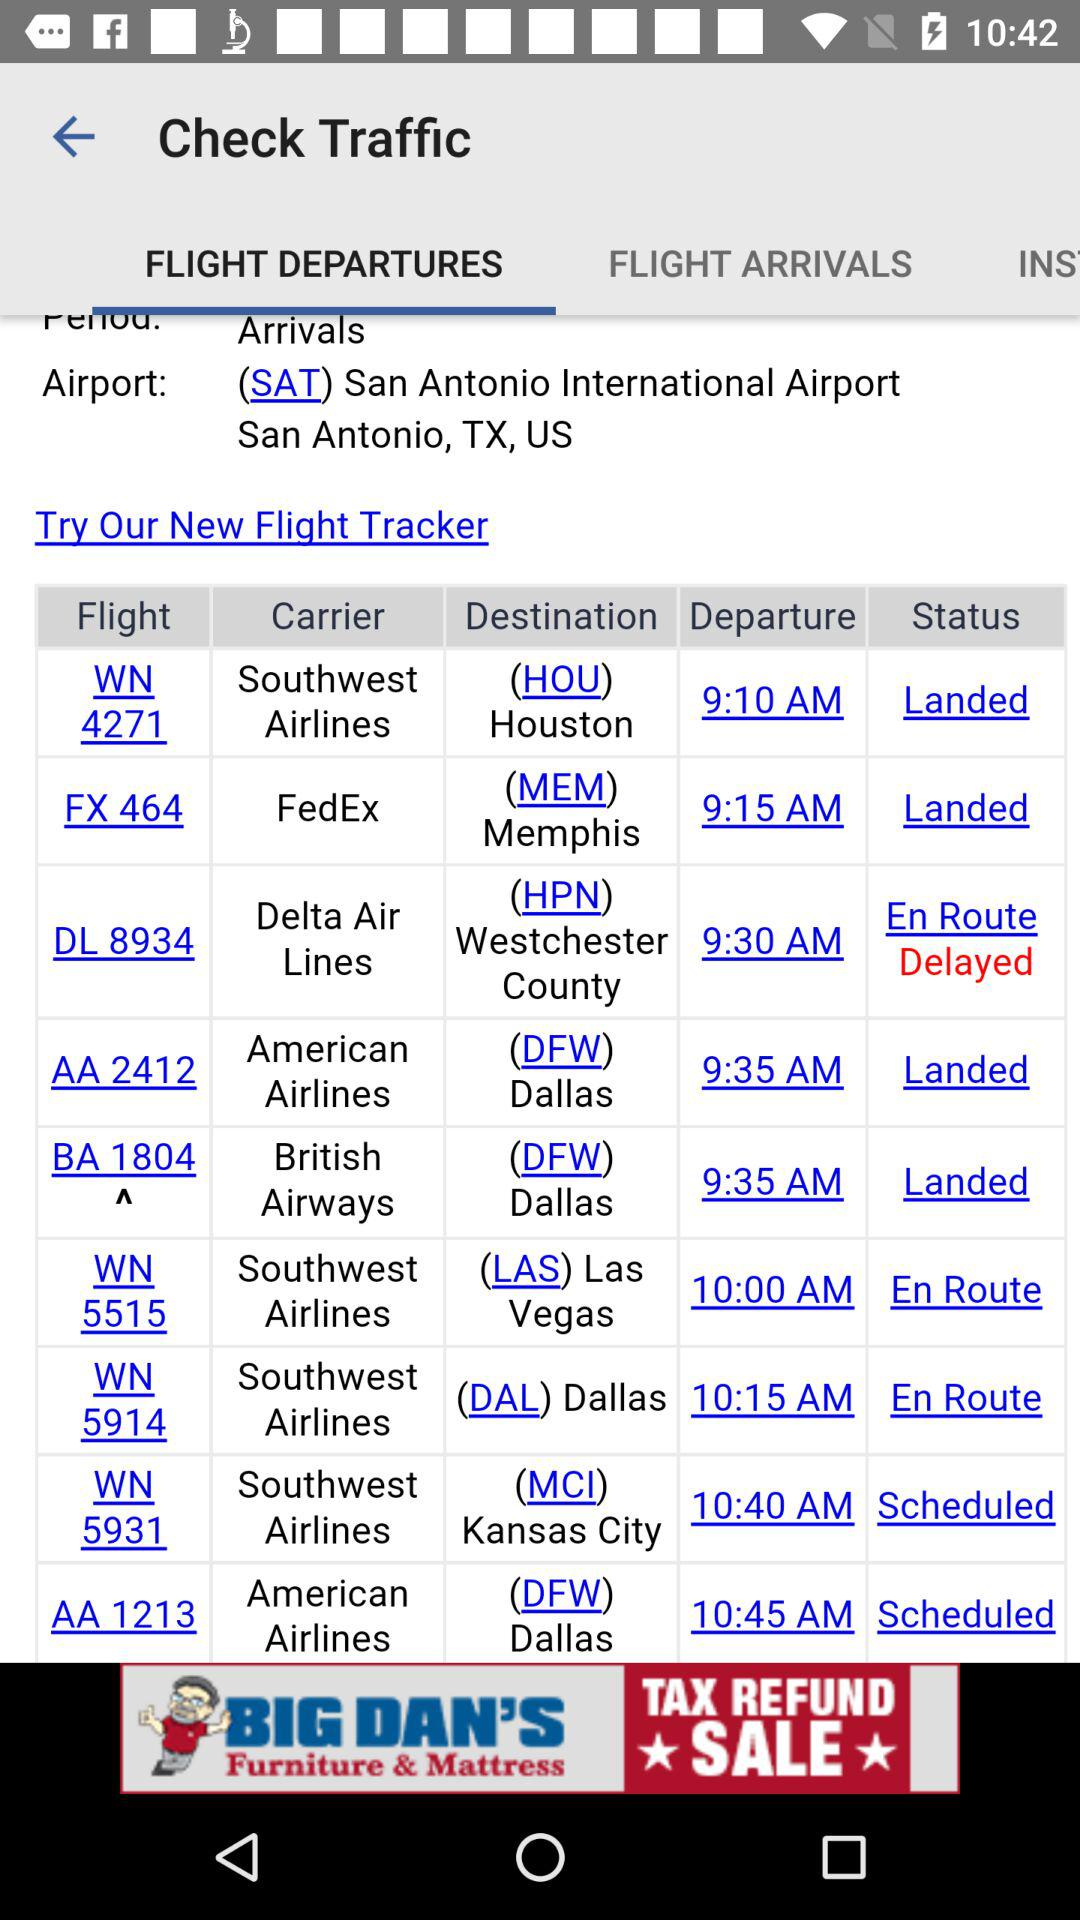What is the departure time of Southwest Airlines flight WN 4271? The departure time is 9:10 a.m. 